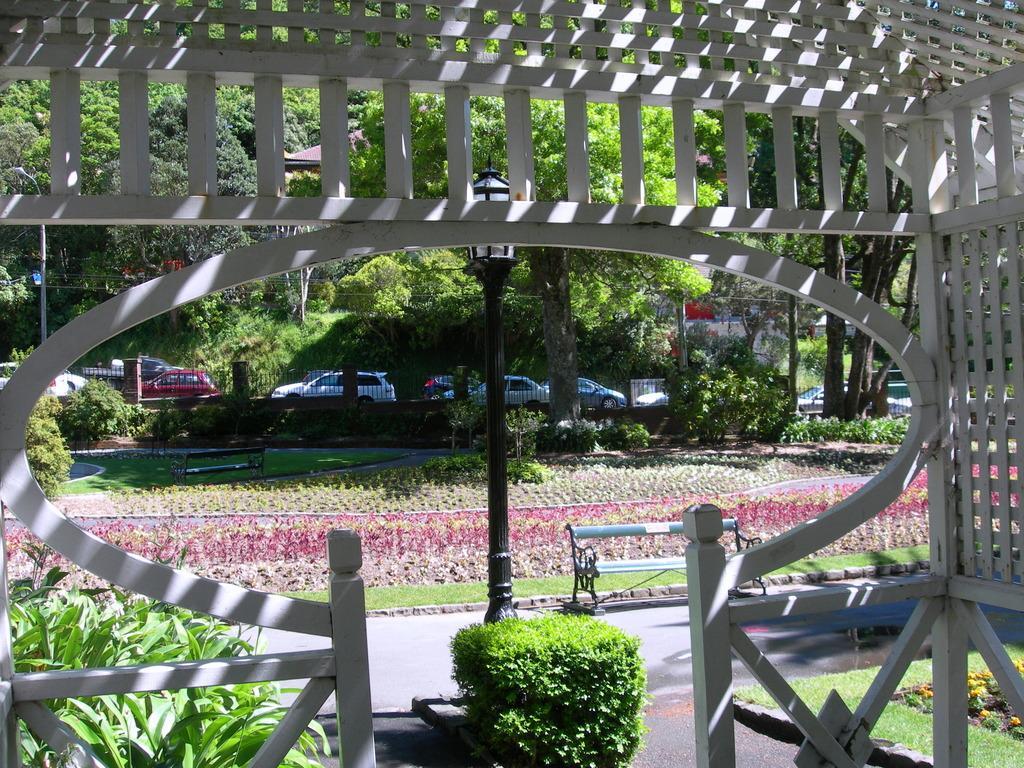Please provide a concise description of this image. In this image I can see it looks like a wooden gate. I can see a bench and a pole on the road. I can see the flowers. In the background, I can see the railing and some vehicles on the road. I also can see the trees. 